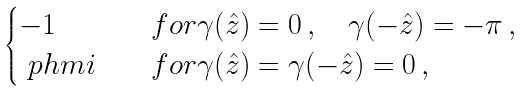<formula> <loc_0><loc_0><loc_500><loc_500>\begin{cases} - 1 & \quad f o r \gamma ( \hat { z } ) = 0 \, , \quad \gamma ( - \hat { z } ) = - \pi \, , \\ \ p h m i & \quad f o r \gamma ( \hat { z } ) = \gamma ( - \hat { z } ) = 0 \, , \end{cases}</formula> 